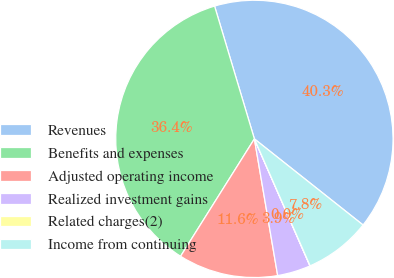Convert chart to OTSL. <chart><loc_0><loc_0><loc_500><loc_500><pie_chart><fcel>Revenues<fcel>Benefits and expenses<fcel>Adjusted operating income<fcel>Realized investment gains<fcel>Related charges(2)<fcel>Income from continuing<nl><fcel>40.3%<fcel>36.43%<fcel>11.62%<fcel>3.88%<fcel>0.02%<fcel>7.75%<nl></chart> 